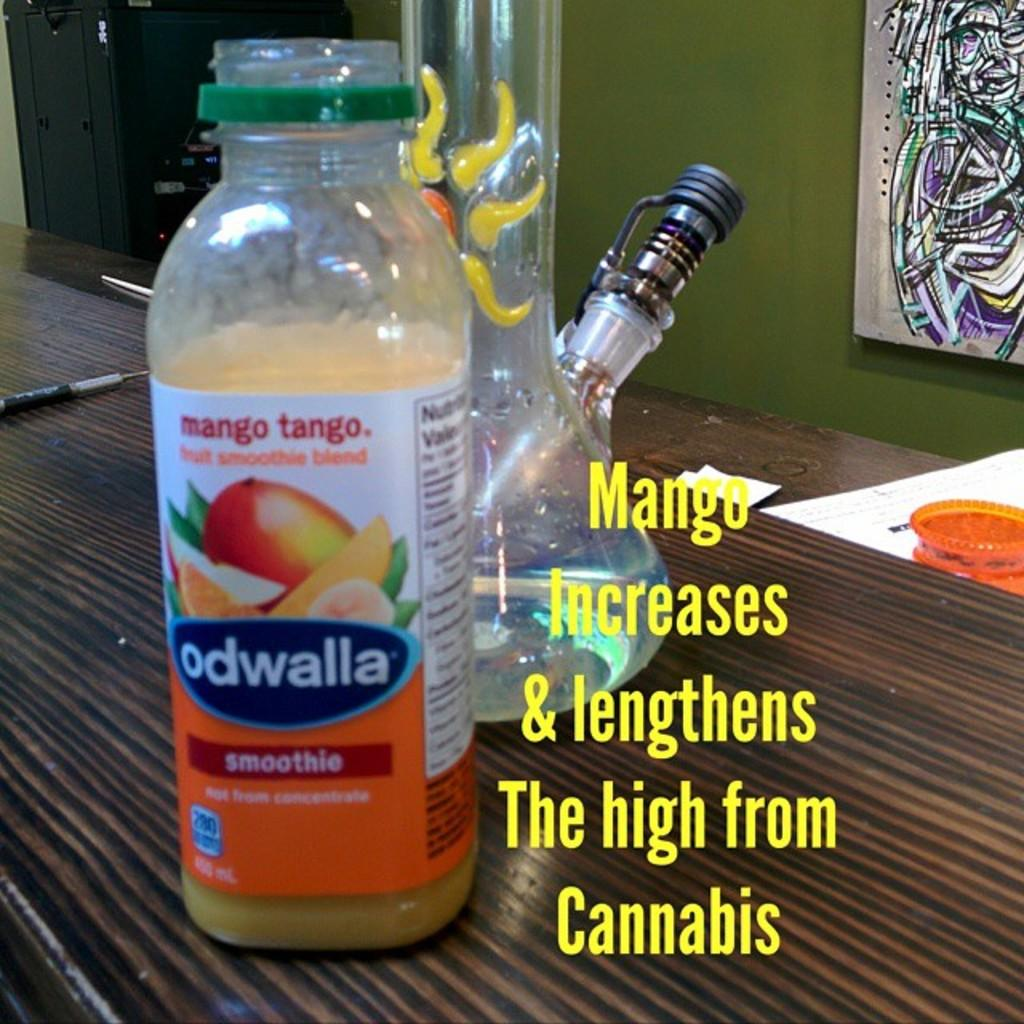<image>
Create a compact narrative representing the image presented. A bottle of Odwalla Mango smoothie sits in front of a bong. 